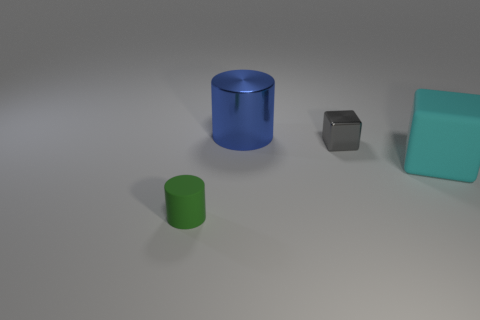Add 3 cyan metal cylinders. How many objects exist? 7 Subtract 1 cylinders. How many cylinders are left? 1 Subtract all blue cylinders. How many cylinders are left? 1 Subtract all gray blocks. Subtract all cyan cylinders. How many blocks are left? 1 Subtract all yellow blocks. How many red cylinders are left? 0 Subtract all tiny green matte cylinders. Subtract all rubber things. How many objects are left? 1 Add 4 cyan blocks. How many cyan blocks are left? 5 Add 1 small purple blocks. How many small purple blocks exist? 1 Subtract 0 purple cylinders. How many objects are left? 4 